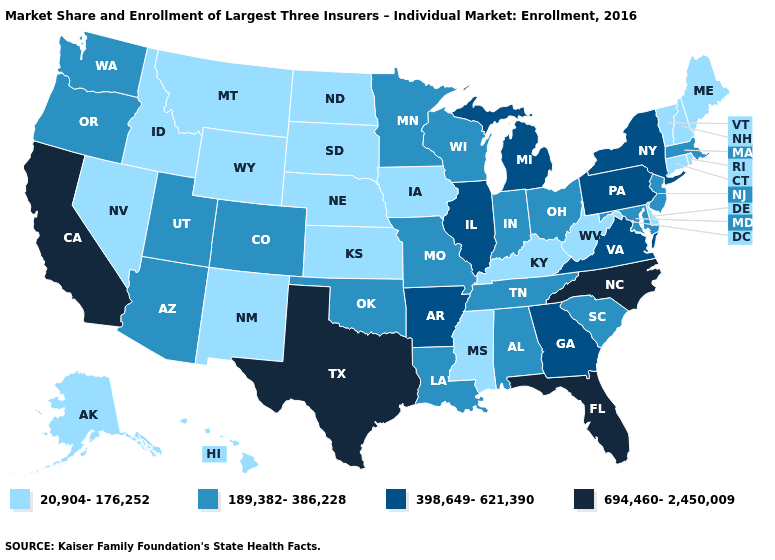Name the states that have a value in the range 189,382-386,228?
Quick response, please. Alabama, Arizona, Colorado, Indiana, Louisiana, Maryland, Massachusetts, Minnesota, Missouri, New Jersey, Ohio, Oklahoma, Oregon, South Carolina, Tennessee, Utah, Washington, Wisconsin. Name the states that have a value in the range 694,460-2,450,009?
Keep it brief. California, Florida, North Carolina, Texas. How many symbols are there in the legend?
Keep it brief. 4. What is the value of Alabama?
Answer briefly. 189,382-386,228. Which states have the lowest value in the USA?
Keep it brief. Alaska, Connecticut, Delaware, Hawaii, Idaho, Iowa, Kansas, Kentucky, Maine, Mississippi, Montana, Nebraska, Nevada, New Hampshire, New Mexico, North Dakota, Rhode Island, South Dakota, Vermont, West Virginia, Wyoming. Does the first symbol in the legend represent the smallest category?
Short answer required. Yes. What is the value of Florida?
Write a very short answer. 694,460-2,450,009. Among the states that border Idaho , does Nevada have the lowest value?
Write a very short answer. Yes. What is the highest value in states that border Kentucky?
Keep it brief. 398,649-621,390. What is the value of Arizona?
Write a very short answer. 189,382-386,228. What is the value of Iowa?
Short answer required. 20,904-176,252. Does the map have missing data?
Write a very short answer. No. How many symbols are there in the legend?
Answer briefly. 4. Among the states that border Connecticut , does Rhode Island have the lowest value?
Answer briefly. Yes. Is the legend a continuous bar?
Write a very short answer. No. 